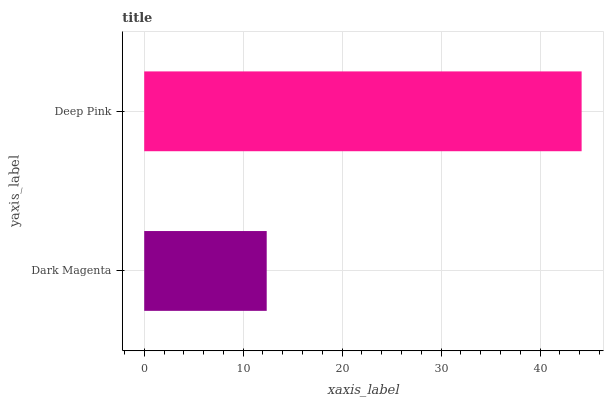Is Dark Magenta the minimum?
Answer yes or no. Yes. Is Deep Pink the maximum?
Answer yes or no. Yes. Is Deep Pink the minimum?
Answer yes or no. No. Is Deep Pink greater than Dark Magenta?
Answer yes or no. Yes. Is Dark Magenta less than Deep Pink?
Answer yes or no. Yes. Is Dark Magenta greater than Deep Pink?
Answer yes or no. No. Is Deep Pink less than Dark Magenta?
Answer yes or no. No. Is Deep Pink the high median?
Answer yes or no. Yes. Is Dark Magenta the low median?
Answer yes or no. Yes. Is Dark Magenta the high median?
Answer yes or no. No. Is Deep Pink the low median?
Answer yes or no. No. 